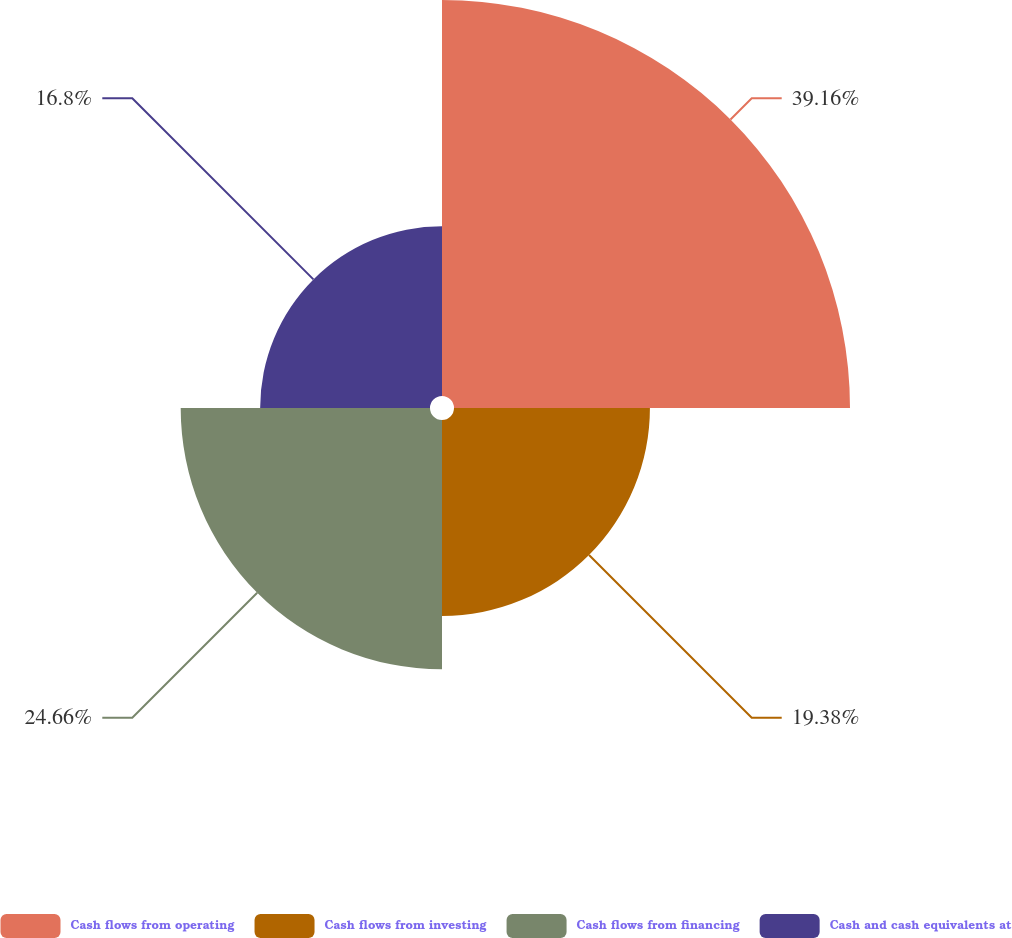<chart> <loc_0><loc_0><loc_500><loc_500><pie_chart><fcel>Cash flows from operating<fcel>Cash flows from investing<fcel>Cash flows from financing<fcel>Cash and cash equivalents at<nl><fcel>39.17%<fcel>19.38%<fcel>24.66%<fcel>16.8%<nl></chart> 